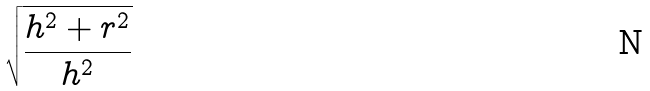<formula> <loc_0><loc_0><loc_500><loc_500>\sqrt { \frac { h ^ { 2 } + r ^ { 2 } } { h ^ { 2 } } }</formula> 